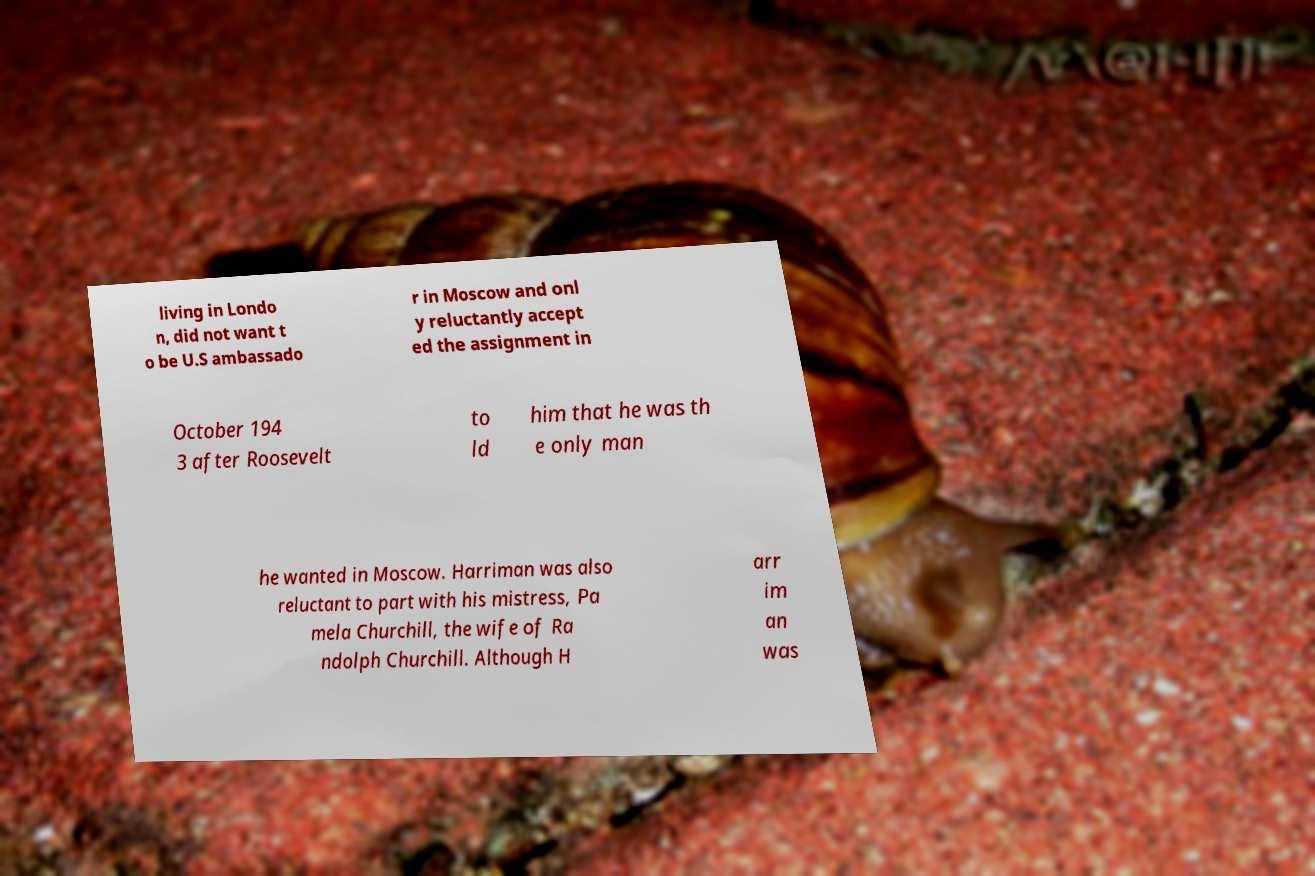There's text embedded in this image that I need extracted. Can you transcribe it verbatim? living in Londo n, did not want t o be U.S ambassado r in Moscow and onl y reluctantly accept ed the assignment in October 194 3 after Roosevelt to ld him that he was th e only man he wanted in Moscow. Harriman was also reluctant to part with his mistress, Pa mela Churchill, the wife of Ra ndolph Churchill. Although H arr im an was 